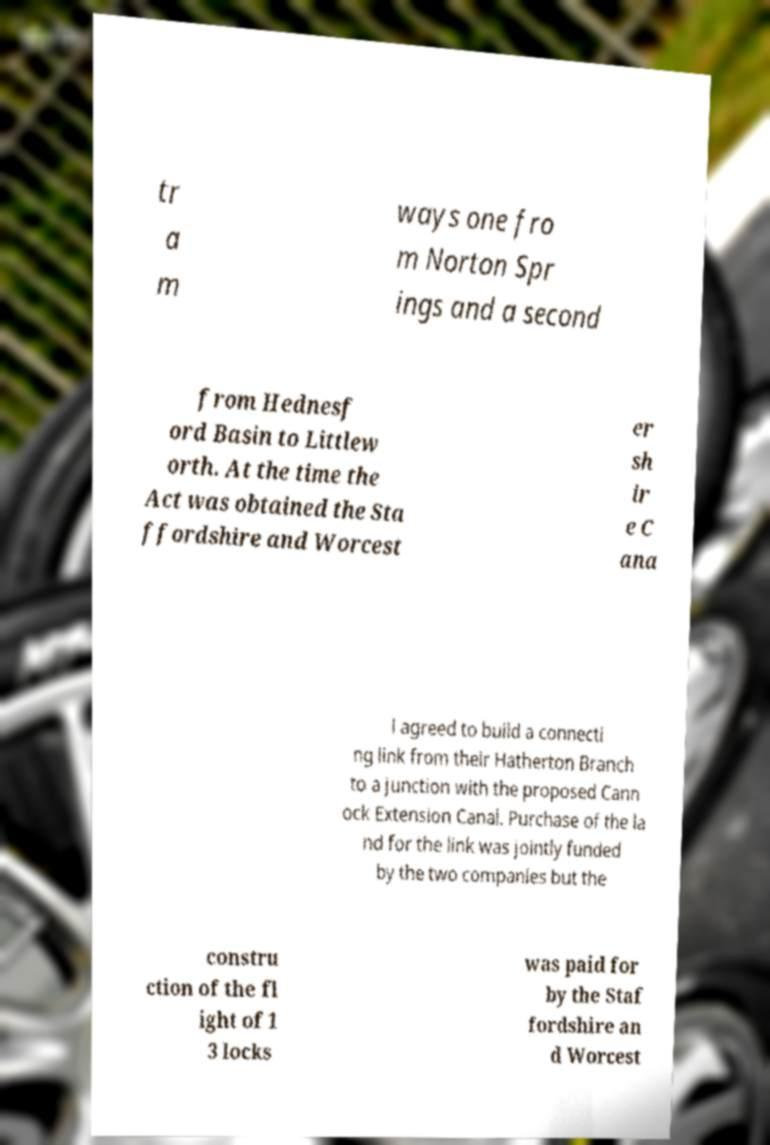Could you assist in decoding the text presented in this image and type it out clearly? tr a m ways one fro m Norton Spr ings and a second from Hednesf ord Basin to Littlew orth. At the time the Act was obtained the Sta ffordshire and Worcest er sh ir e C ana l agreed to build a connecti ng link from their Hatherton Branch to a junction with the proposed Cann ock Extension Canal. Purchase of the la nd for the link was jointly funded by the two companies but the constru ction of the fl ight of 1 3 locks was paid for by the Staf fordshire an d Worcest 